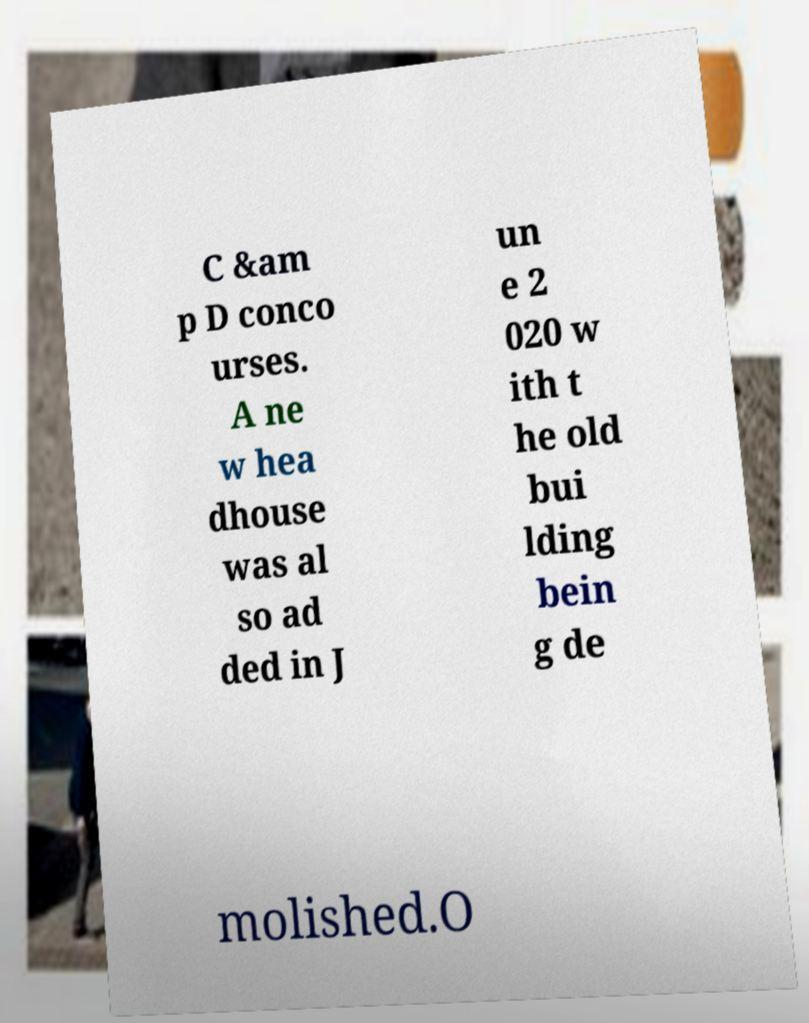I need the written content from this picture converted into text. Can you do that? C &am p D conco urses. A ne w hea dhouse was al so ad ded in J un e 2 020 w ith t he old bui lding bein g de molished.O 